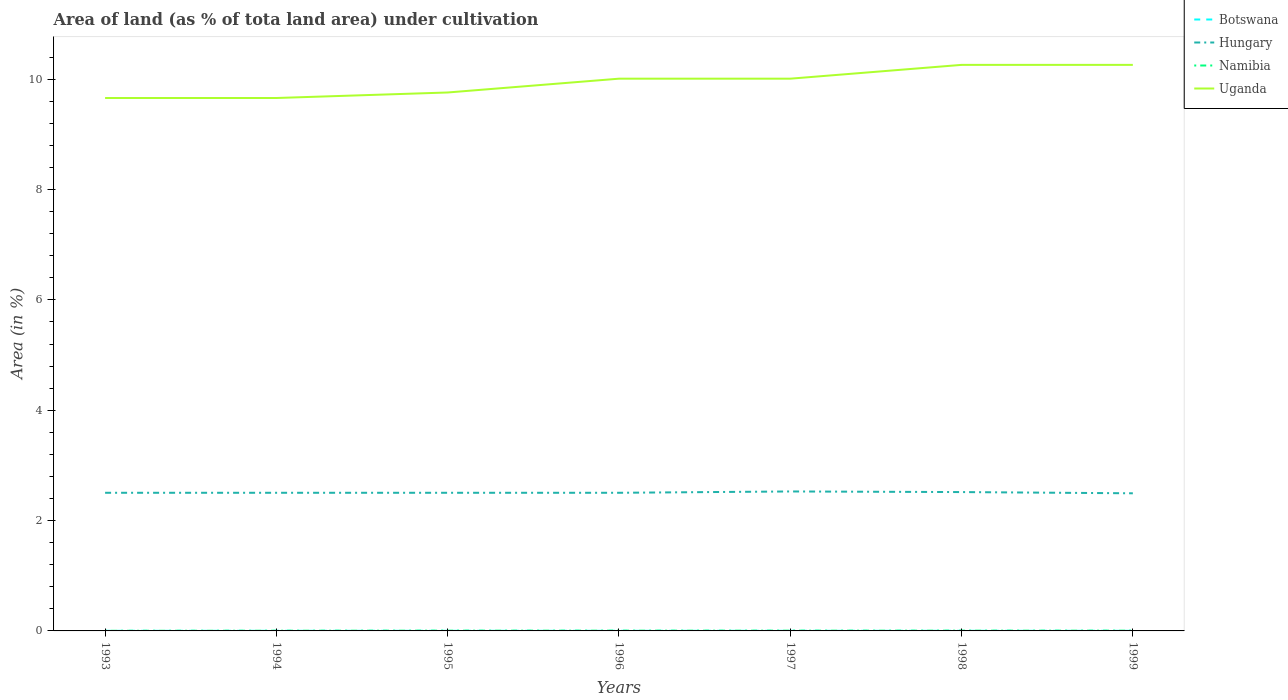Does the line corresponding to Namibia intersect with the line corresponding to Botswana?
Your answer should be very brief. No. Across all years, what is the maximum percentage of land under cultivation in Hungary?
Your answer should be compact. 2.49. In which year was the percentage of land under cultivation in Uganda maximum?
Offer a very short reply. 1993. What is the total percentage of land under cultivation in Uganda in the graph?
Your answer should be compact. -0.25. What is the difference between the highest and the second highest percentage of land under cultivation in Namibia?
Make the answer very short. 0. Where does the legend appear in the graph?
Provide a short and direct response. Top right. How many legend labels are there?
Your response must be concise. 4. How are the legend labels stacked?
Provide a short and direct response. Vertical. What is the title of the graph?
Give a very brief answer. Area of land (as % of tota land area) under cultivation. Does "Ghana" appear as one of the legend labels in the graph?
Make the answer very short. No. What is the label or title of the Y-axis?
Make the answer very short. Area (in %). What is the Area (in %) in Botswana in 1993?
Ensure brevity in your answer.  0. What is the Area (in %) in Hungary in 1993?
Keep it short and to the point. 2.5. What is the Area (in %) in Namibia in 1993?
Provide a succinct answer. 0. What is the Area (in %) in Uganda in 1993?
Make the answer very short. 9.66. What is the Area (in %) of Botswana in 1994?
Offer a terse response. 0. What is the Area (in %) of Hungary in 1994?
Provide a succinct answer. 2.5. What is the Area (in %) in Namibia in 1994?
Your answer should be very brief. 0. What is the Area (in %) of Uganda in 1994?
Ensure brevity in your answer.  9.66. What is the Area (in %) of Botswana in 1995?
Your response must be concise. 0. What is the Area (in %) in Hungary in 1995?
Offer a terse response. 2.5. What is the Area (in %) in Namibia in 1995?
Offer a terse response. 0. What is the Area (in %) in Uganda in 1995?
Keep it short and to the point. 9.76. What is the Area (in %) in Botswana in 1996?
Keep it short and to the point. 0. What is the Area (in %) of Hungary in 1996?
Your answer should be very brief. 2.5. What is the Area (in %) in Namibia in 1996?
Offer a terse response. 0. What is the Area (in %) of Uganda in 1996?
Your answer should be compact. 10.01. What is the Area (in %) of Botswana in 1997?
Your answer should be very brief. 0. What is the Area (in %) of Hungary in 1997?
Offer a terse response. 2.53. What is the Area (in %) of Namibia in 1997?
Give a very brief answer. 0. What is the Area (in %) of Uganda in 1997?
Your answer should be very brief. 10.01. What is the Area (in %) in Botswana in 1998?
Give a very brief answer. 0. What is the Area (in %) of Hungary in 1998?
Offer a terse response. 2.52. What is the Area (in %) of Namibia in 1998?
Your answer should be very brief. 0. What is the Area (in %) of Uganda in 1998?
Your response must be concise. 10.26. What is the Area (in %) in Botswana in 1999?
Your answer should be compact. 0. What is the Area (in %) in Hungary in 1999?
Give a very brief answer. 2.49. What is the Area (in %) of Namibia in 1999?
Make the answer very short. 0. What is the Area (in %) of Uganda in 1999?
Offer a terse response. 10.26. Across all years, what is the maximum Area (in %) of Botswana?
Make the answer very short. 0. Across all years, what is the maximum Area (in %) of Hungary?
Make the answer very short. 2.53. Across all years, what is the maximum Area (in %) in Namibia?
Your answer should be compact. 0. Across all years, what is the maximum Area (in %) of Uganda?
Offer a very short reply. 10.26. Across all years, what is the minimum Area (in %) in Botswana?
Offer a terse response. 0. Across all years, what is the minimum Area (in %) of Hungary?
Offer a very short reply. 2.49. Across all years, what is the minimum Area (in %) of Namibia?
Keep it short and to the point. 0. Across all years, what is the minimum Area (in %) of Uganda?
Your answer should be very brief. 9.66. What is the total Area (in %) of Botswana in the graph?
Provide a short and direct response. 0.01. What is the total Area (in %) of Hungary in the graph?
Give a very brief answer. 17.55. What is the total Area (in %) in Namibia in the graph?
Make the answer very short. 0.03. What is the total Area (in %) of Uganda in the graph?
Your answer should be very brief. 69.62. What is the difference between the Area (in %) in Botswana in 1993 and that in 1994?
Offer a very short reply. 0. What is the difference between the Area (in %) of Namibia in 1993 and that in 1994?
Ensure brevity in your answer.  -0. What is the difference between the Area (in %) in Hungary in 1993 and that in 1995?
Provide a short and direct response. 0. What is the difference between the Area (in %) of Namibia in 1993 and that in 1995?
Offer a terse response. -0. What is the difference between the Area (in %) in Uganda in 1993 and that in 1995?
Keep it short and to the point. -0.1. What is the difference between the Area (in %) of Namibia in 1993 and that in 1996?
Give a very brief answer. -0. What is the difference between the Area (in %) in Uganda in 1993 and that in 1996?
Provide a short and direct response. -0.35. What is the difference between the Area (in %) in Hungary in 1993 and that in 1997?
Keep it short and to the point. -0.02. What is the difference between the Area (in %) in Namibia in 1993 and that in 1997?
Your response must be concise. -0. What is the difference between the Area (in %) in Uganda in 1993 and that in 1997?
Give a very brief answer. -0.35. What is the difference between the Area (in %) of Hungary in 1993 and that in 1998?
Provide a short and direct response. -0.01. What is the difference between the Area (in %) in Namibia in 1993 and that in 1998?
Provide a succinct answer. -0. What is the difference between the Area (in %) of Uganda in 1993 and that in 1998?
Give a very brief answer. -0.6. What is the difference between the Area (in %) in Botswana in 1993 and that in 1999?
Your answer should be very brief. 0. What is the difference between the Area (in %) of Hungary in 1993 and that in 1999?
Offer a terse response. 0.01. What is the difference between the Area (in %) of Namibia in 1993 and that in 1999?
Provide a short and direct response. -0. What is the difference between the Area (in %) in Uganda in 1993 and that in 1999?
Give a very brief answer. -0.6. What is the difference between the Area (in %) of Namibia in 1994 and that in 1995?
Give a very brief answer. -0. What is the difference between the Area (in %) in Uganda in 1994 and that in 1995?
Your response must be concise. -0.1. What is the difference between the Area (in %) of Botswana in 1994 and that in 1996?
Make the answer very short. 0. What is the difference between the Area (in %) in Namibia in 1994 and that in 1996?
Offer a very short reply. -0. What is the difference between the Area (in %) of Uganda in 1994 and that in 1996?
Your answer should be compact. -0.35. What is the difference between the Area (in %) of Hungary in 1994 and that in 1997?
Keep it short and to the point. -0.02. What is the difference between the Area (in %) of Namibia in 1994 and that in 1997?
Your answer should be very brief. -0. What is the difference between the Area (in %) of Uganda in 1994 and that in 1997?
Provide a succinct answer. -0.35. What is the difference between the Area (in %) of Hungary in 1994 and that in 1998?
Offer a very short reply. -0.01. What is the difference between the Area (in %) in Namibia in 1994 and that in 1998?
Make the answer very short. -0. What is the difference between the Area (in %) in Uganda in 1994 and that in 1998?
Keep it short and to the point. -0.6. What is the difference between the Area (in %) in Hungary in 1994 and that in 1999?
Make the answer very short. 0.01. What is the difference between the Area (in %) of Namibia in 1994 and that in 1999?
Ensure brevity in your answer.  -0. What is the difference between the Area (in %) in Uganda in 1994 and that in 1999?
Your answer should be compact. -0.6. What is the difference between the Area (in %) in Uganda in 1995 and that in 1996?
Your answer should be very brief. -0.25. What is the difference between the Area (in %) of Botswana in 1995 and that in 1997?
Your answer should be very brief. 0. What is the difference between the Area (in %) in Hungary in 1995 and that in 1997?
Offer a very short reply. -0.02. What is the difference between the Area (in %) of Uganda in 1995 and that in 1997?
Offer a very short reply. -0.25. What is the difference between the Area (in %) of Hungary in 1995 and that in 1998?
Offer a very short reply. -0.01. What is the difference between the Area (in %) of Namibia in 1995 and that in 1998?
Your response must be concise. 0. What is the difference between the Area (in %) in Uganda in 1995 and that in 1998?
Ensure brevity in your answer.  -0.5. What is the difference between the Area (in %) in Hungary in 1995 and that in 1999?
Provide a short and direct response. 0.01. What is the difference between the Area (in %) of Uganda in 1995 and that in 1999?
Provide a succinct answer. -0.5. What is the difference between the Area (in %) in Botswana in 1996 and that in 1997?
Your answer should be compact. 0. What is the difference between the Area (in %) of Hungary in 1996 and that in 1997?
Give a very brief answer. -0.02. What is the difference between the Area (in %) in Uganda in 1996 and that in 1997?
Offer a terse response. 0. What is the difference between the Area (in %) in Botswana in 1996 and that in 1998?
Make the answer very short. 0. What is the difference between the Area (in %) of Hungary in 1996 and that in 1998?
Keep it short and to the point. -0.01. What is the difference between the Area (in %) in Namibia in 1996 and that in 1998?
Your answer should be compact. 0. What is the difference between the Area (in %) of Uganda in 1996 and that in 1998?
Keep it short and to the point. -0.25. What is the difference between the Area (in %) in Hungary in 1996 and that in 1999?
Your answer should be very brief. 0.01. What is the difference between the Area (in %) in Uganda in 1996 and that in 1999?
Your answer should be compact. -0.25. What is the difference between the Area (in %) of Botswana in 1997 and that in 1998?
Make the answer very short. 0. What is the difference between the Area (in %) of Hungary in 1997 and that in 1998?
Give a very brief answer. 0.01. What is the difference between the Area (in %) in Uganda in 1997 and that in 1998?
Keep it short and to the point. -0.25. What is the difference between the Area (in %) in Hungary in 1997 and that in 1999?
Your answer should be compact. 0.03. What is the difference between the Area (in %) of Namibia in 1997 and that in 1999?
Keep it short and to the point. 0. What is the difference between the Area (in %) of Uganda in 1997 and that in 1999?
Keep it short and to the point. -0.25. What is the difference between the Area (in %) of Botswana in 1998 and that in 1999?
Offer a very short reply. 0. What is the difference between the Area (in %) of Hungary in 1998 and that in 1999?
Keep it short and to the point. 0.02. What is the difference between the Area (in %) in Botswana in 1993 and the Area (in %) in Hungary in 1994?
Ensure brevity in your answer.  -2.5. What is the difference between the Area (in %) in Botswana in 1993 and the Area (in %) in Namibia in 1994?
Provide a succinct answer. -0. What is the difference between the Area (in %) of Botswana in 1993 and the Area (in %) of Uganda in 1994?
Your response must be concise. -9.66. What is the difference between the Area (in %) of Hungary in 1993 and the Area (in %) of Namibia in 1994?
Your answer should be compact. 2.5. What is the difference between the Area (in %) of Hungary in 1993 and the Area (in %) of Uganda in 1994?
Offer a very short reply. -7.16. What is the difference between the Area (in %) of Namibia in 1993 and the Area (in %) of Uganda in 1994?
Keep it short and to the point. -9.66. What is the difference between the Area (in %) of Botswana in 1993 and the Area (in %) of Hungary in 1995?
Offer a terse response. -2.5. What is the difference between the Area (in %) in Botswana in 1993 and the Area (in %) in Namibia in 1995?
Your response must be concise. -0. What is the difference between the Area (in %) of Botswana in 1993 and the Area (in %) of Uganda in 1995?
Your answer should be compact. -9.76. What is the difference between the Area (in %) of Hungary in 1993 and the Area (in %) of Namibia in 1995?
Provide a succinct answer. 2.5. What is the difference between the Area (in %) in Hungary in 1993 and the Area (in %) in Uganda in 1995?
Offer a terse response. -7.26. What is the difference between the Area (in %) in Namibia in 1993 and the Area (in %) in Uganda in 1995?
Ensure brevity in your answer.  -9.76. What is the difference between the Area (in %) in Botswana in 1993 and the Area (in %) in Hungary in 1996?
Your response must be concise. -2.5. What is the difference between the Area (in %) in Botswana in 1993 and the Area (in %) in Namibia in 1996?
Your answer should be compact. -0. What is the difference between the Area (in %) in Botswana in 1993 and the Area (in %) in Uganda in 1996?
Offer a very short reply. -10.01. What is the difference between the Area (in %) of Hungary in 1993 and the Area (in %) of Namibia in 1996?
Offer a terse response. 2.5. What is the difference between the Area (in %) in Hungary in 1993 and the Area (in %) in Uganda in 1996?
Offer a very short reply. -7.51. What is the difference between the Area (in %) of Namibia in 1993 and the Area (in %) of Uganda in 1996?
Make the answer very short. -10.01. What is the difference between the Area (in %) in Botswana in 1993 and the Area (in %) in Hungary in 1997?
Your response must be concise. -2.53. What is the difference between the Area (in %) of Botswana in 1993 and the Area (in %) of Namibia in 1997?
Make the answer very short. -0. What is the difference between the Area (in %) of Botswana in 1993 and the Area (in %) of Uganda in 1997?
Offer a terse response. -10.01. What is the difference between the Area (in %) in Hungary in 1993 and the Area (in %) in Namibia in 1997?
Make the answer very short. 2.5. What is the difference between the Area (in %) in Hungary in 1993 and the Area (in %) in Uganda in 1997?
Offer a terse response. -7.51. What is the difference between the Area (in %) in Namibia in 1993 and the Area (in %) in Uganda in 1997?
Your answer should be very brief. -10.01. What is the difference between the Area (in %) of Botswana in 1993 and the Area (in %) of Hungary in 1998?
Offer a very short reply. -2.51. What is the difference between the Area (in %) of Botswana in 1993 and the Area (in %) of Namibia in 1998?
Keep it short and to the point. -0. What is the difference between the Area (in %) of Botswana in 1993 and the Area (in %) of Uganda in 1998?
Your answer should be compact. -10.26. What is the difference between the Area (in %) of Hungary in 1993 and the Area (in %) of Namibia in 1998?
Your response must be concise. 2.5. What is the difference between the Area (in %) of Hungary in 1993 and the Area (in %) of Uganda in 1998?
Offer a terse response. -7.76. What is the difference between the Area (in %) of Namibia in 1993 and the Area (in %) of Uganda in 1998?
Offer a terse response. -10.26. What is the difference between the Area (in %) in Botswana in 1993 and the Area (in %) in Hungary in 1999?
Your answer should be compact. -2.49. What is the difference between the Area (in %) of Botswana in 1993 and the Area (in %) of Namibia in 1999?
Ensure brevity in your answer.  -0. What is the difference between the Area (in %) in Botswana in 1993 and the Area (in %) in Uganda in 1999?
Your answer should be compact. -10.26. What is the difference between the Area (in %) in Hungary in 1993 and the Area (in %) in Namibia in 1999?
Provide a short and direct response. 2.5. What is the difference between the Area (in %) of Hungary in 1993 and the Area (in %) of Uganda in 1999?
Your response must be concise. -7.76. What is the difference between the Area (in %) of Namibia in 1993 and the Area (in %) of Uganda in 1999?
Ensure brevity in your answer.  -10.26. What is the difference between the Area (in %) of Botswana in 1994 and the Area (in %) of Hungary in 1995?
Provide a succinct answer. -2.5. What is the difference between the Area (in %) in Botswana in 1994 and the Area (in %) in Namibia in 1995?
Make the answer very short. -0. What is the difference between the Area (in %) of Botswana in 1994 and the Area (in %) of Uganda in 1995?
Offer a very short reply. -9.76. What is the difference between the Area (in %) of Hungary in 1994 and the Area (in %) of Namibia in 1995?
Offer a very short reply. 2.5. What is the difference between the Area (in %) in Hungary in 1994 and the Area (in %) in Uganda in 1995?
Your answer should be very brief. -7.26. What is the difference between the Area (in %) in Namibia in 1994 and the Area (in %) in Uganda in 1995?
Your response must be concise. -9.76. What is the difference between the Area (in %) in Botswana in 1994 and the Area (in %) in Hungary in 1996?
Give a very brief answer. -2.5. What is the difference between the Area (in %) of Botswana in 1994 and the Area (in %) of Namibia in 1996?
Your answer should be compact. -0. What is the difference between the Area (in %) in Botswana in 1994 and the Area (in %) in Uganda in 1996?
Keep it short and to the point. -10.01. What is the difference between the Area (in %) of Hungary in 1994 and the Area (in %) of Namibia in 1996?
Keep it short and to the point. 2.5. What is the difference between the Area (in %) in Hungary in 1994 and the Area (in %) in Uganda in 1996?
Provide a succinct answer. -7.51. What is the difference between the Area (in %) of Namibia in 1994 and the Area (in %) of Uganda in 1996?
Provide a succinct answer. -10.01. What is the difference between the Area (in %) of Botswana in 1994 and the Area (in %) of Hungary in 1997?
Make the answer very short. -2.53. What is the difference between the Area (in %) in Botswana in 1994 and the Area (in %) in Namibia in 1997?
Keep it short and to the point. -0. What is the difference between the Area (in %) in Botswana in 1994 and the Area (in %) in Uganda in 1997?
Make the answer very short. -10.01. What is the difference between the Area (in %) of Hungary in 1994 and the Area (in %) of Namibia in 1997?
Provide a succinct answer. 2.5. What is the difference between the Area (in %) of Hungary in 1994 and the Area (in %) of Uganda in 1997?
Offer a terse response. -7.51. What is the difference between the Area (in %) of Namibia in 1994 and the Area (in %) of Uganda in 1997?
Make the answer very short. -10.01. What is the difference between the Area (in %) in Botswana in 1994 and the Area (in %) in Hungary in 1998?
Make the answer very short. -2.51. What is the difference between the Area (in %) of Botswana in 1994 and the Area (in %) of Namibia in 1998?
Keep it short and to the point. -0. What is the difference between the Area (in %) in Botswana in 1994 and the Area (in %) in Uganda in 1998?
Keep it short and to the point. -10.26. What is the difference between the Area (in %) in Hungary in 1994 and the Area (in %) in Namibia in 1998?
Provide a succinct answer. 2.5. What is the difference between the Area (in %) in Hungary in 1994 and the Area (in %) in Uganda in 1998?
Ensure brevity in your answer.  -7.76. What is the difference between the Area (in %) in Namibia in 1994 and the Area (in %) in Uganda in 1998?
Make the answer very short. -10.26. What is the difference between the Area (in %) in Botswana in 1994 and the Area (in %) in Hungary in 1999?
Ensure brevity in your answer.  -2.49. What is the difference between the Area (in %) in Botswana in 1994 and the Area (in %) in Namibia in 1999?
Your response must be concise. -0. What is the difference between the Area (in %) in Botswana in 1994 and the Area (in %) in Uganda in 1999?
Offer a very short reply. -10.26. What is the difference between the Area (in %) of Hungary in 1994 and the Area (in %) of Namibia in 1999?
Your answer should be very brief. 2.5. What is the difference between the Area (in %) in Hungary in 1994 and the Area (in %) in Uganda in 1999?
Keep it short and to the point. -7.76. What is the difference between the Area (in %) of Namibia in 1994 and the Area (in %) of Uganda in 1999?
Make the answer very short. -10.26. What is the difference between the Area (in %) of Botswana in 1995 and the Area (in %) of Hungary in 1996?
Offer a terse response. -2.5. What is the difference between the Area (in %) in Botswana in 1995 and the Area (in %) in Namibia in 1996?
Give a very brief answer. -0. What is the difference between the Area (in %) in Botswana in 1995 and the Area (in %) in Uganda in 1996?
Your response must be concise. -10.01. What is the difference between the Area (in %) in Hungary in 1995 and the Area (in %) in Namibia in 1996?
Keep it short and to the point. 2.5. What is the difference between the Area (in %) of Hungary in 1995 and the Area (in %) of Uganda in 1996?
Give a very brief answer. -7.51. What is the difference between the Area (in %) in Namibia in 1995 and the Area (in %) in Uganda in 1996?
Your response must be concise. -10. What is the difference between the Area (in %) of Botswana in 1995 and the Area (in %) of Hungary in 1997?
Give a very brief answer. -2.53. What is the difference between the Area (in %) in Botswana in 1995 and the Area (in %) in Namibia in 1997?
Give a very brief answer. -0. What is the difference between the Area (in %) in Botswana in 1995 and the Area (in %) in Uganda in 1997?
Make the answer very short. -10.01. What is the difference between the Area (in %) in Hungary in 1995 and the Area (in %) in Namibia in 1997?
Make the answer very short. 2.5. What is the difference between the Area (in %) in Hungary in 1995 and the Area (in %) in Uganda in 1997?
Provide a succinct answer. -7.51. What is the difference between the Area (in %) of Namibia in 1995 and the Area (in %) of Uganda in 1997?
Keep it short and to the point. -10. What is the difference between the Area (in %) in Botswana in 1995 and the Area (in %) in Hungary in 1998?
Offer a terse response. -2.51. What is the difference between the Area (in %) of Botswana in 1995 and the Area (in %) of Namibia in 1998?
Offer a terse response. -0. What is the difference between the Area (in %) of Botswana in 1995 and the Area (in %) of Uganda in 1998?
Give a very brief answer. -10.26. What is the difference between the Area (in %) in Hungary in 1995 and the Area (in %) in Namibia in 1998?
Provide a short and direct response. 2.5. What is the difference between the Area (in %) of Hungary in 1995 and the Area (in %) of Uganda in 1998?
Keep it short and to the point. -7.76. What is the difference between the Area (in %) of Namibia in 1995 and the Area (in %) of Uganda in 1998?
Offer a terse response. -10.25. What is the difference between the Area (in %) in Botswana in 1995 and the Area (in %) in Hungary in 1999?
Ensure brevity in your answer.  -2.49. What is the difference between the Area (in %) in Botswana in 1995 and the Area (in %) in Namibia in 1999?
Offer a terse response. -0. What is the difference between the Area (in %) in Botswana in 1995 and the Area (in %) in Uganda in 1999?
Your response must be concise. -10.26. What is the difference between the Area (in %) in Hungary in 1995 and the Area (in %) in Namibia in 1999?
Make the answer very short. 2.5. What is the difference between the Area (in %) in Hungary in 1995 and the Area (in %) in Uganda in 1999?
Give a very brief answer. -7.76. What is the difference between the Area (in %) of Namibia in 1995 and the Area (in %) of Uganda in 1999?
Provide a succinct answer. -10.25. What is the difference between the Area (in %) of Botswana in 1996 and the Area (in %) of Hungary in 1997?
Offer a terse response. -2.53. What is the difference between the Area (in %) in Botswana in 1996 and the Area (in %) in Namibia in 1997?
Your response must be concise. -0. What is the difference between the Area (in %) of Botswana in 1996 and the Area (in %) of Uganda in 1997?
Keep it short and to the point. -10.01. What is the difference between the Area (in %) in Hungary in 1996 and the Area (in %) in Namibia in 1997?
Your answer should be compact. 2.5. What is the difference between the Area (in %) in Hungary in 1996 and the Area (in %) in Uganda in 1997?
Offer a terse response. -7.51. What is the difference between the Area (in %) in Namibia in 1996 and the Area (in %) in Uganda in 1997?
Give a very brief answer. -10. What is the difference between the Area (in %) of Botswana in 1996 and the Area (in %) of Hungary in 1998?
Give a very brief answer. -2.51. What is the difference between the Area (in %) of Botswana in 1996 and the Area (in %) of Namibia in 1998?
Your answer should be very brief. -0. What is the difference between the Area (in %) of Botswana in 1996 and the Area (in %) of Uganda in 1998?
Ensure brevity in your answer.  -10.26. What is the difference between the Area (in %) of Hungary in 1996 and the Area (in %) of Namibia in 1998?
Your response must be concise. 2.5. What is the difference between the Area (in %) of Hungary in 1996 and the Area (in %) of Uganda in 1998?
Offer a very short reply. -7.76. What is the difference between the Area (in %) of Namibia in 1996 and the Area (in %) of Uganda in 1998?
Your response must be concise. -10.25. What is the difference between the Area (in %) in Botswana in 1996 and the Area (in %) in Hungary in 1999?
Offer a terse response. -2.49. What is the difference between the Area (in %) in Botswana in 1996 and the Area (in %) in Namibia in 1999?
Provide a succinct answer. -0. What is the difference between the Area (in %) in Botswana in 1996 and the Area (in %) in Uganda in 1999?
Your response must be concise. -10.26. What is the difference between the Area (in %) in Hungary in 1996 and the Area (in %) in Namibia in 1999?
Ensure brevity in your answer.  2.5. What is the difference between the Area (in %) of Hungary in 1996 and the Area (in %) of Uganda in 1999?
Your answer should be compact. -7.76. What is the difference between the Area (in %) in Namibia in 1996 and the Area (in %) in Uganda in 1999?
Provide a succinct answer. -10.25. What is the difference between the Area (in %) of Botswana in 1997 and the Area (in %) of Hungary in 1998?
Your answer should be compact. -2.51. What is the difference between the Area (in %) of Botswana in 1997 and the Area (in %) of Namibia in 1998?
Your answer should be very brief. -0. What is the difference between the Area (in %) in Botswana in 1997 and the Area (in %) in Uganda in 1998?
Give a very brief answer. -10.26. What is the difference between the Area (in %) in Hungary in 1997 and the Area (in %) in Namibia in 1998?
Keep it short and to the point. 2.52. What is the difference between the Area (in %) of Hungary in 1997 and the Area (in %) of Uganda in 1998?
Make the answer very short. -7.73. What is the difference between the Area (in %) in Namibia in 1997 and the Area (in %) in Uganda in 1998?
Provide a succinct answer. -10.25. What is the difference between the Area (in %) of Botswana in 1997 and the Area (in %) of Hungary in 1999?
Give a very brief answer. -2.49. What is the difference between the Area (in %) in Botswana in 1997 and the Area (in %) in Namibia in 1999?
Offer a terse response. -0. What is the difference between the Area (in %) in Botswana in 1997 and the Area (in %) in Uganda in 1999?
Make the answer very short. -10.26. What is the difference between the Area (in %) in Hungary in 1997 and the Area (in %) in Namibia in 1999?
Offer a terse response. 2.52. What is the difference between the Area (in %) of Hungary in 1997 and the Area (in %) of Uganda in 1999?
Your answer should be compact. -7.73. What is the difference between the Area (in %) of Namibia in 1997 and the Area (in %) of Uganda in 1999?
Keep it short and to the point. -10.25. What is the difference between the Area (in %) in Botswana in 1998 and the Area (in %) in Hungary in 1999?
Your answer should be very brief. -2.49. What is the difference between the Area (in %) of Botswana in 1998 and the Area (in %) of Namibia in 1999?
Provide a short and direct response. -0. What is the difference between the Area (in %) of Botswana in 1998 and the Area (in %) of Uganda in 1999?
Give a very brief answer. -10.26. What is the difference between the Area (in %) of Hungary in 1998 and the Area (in %) of Namibia in 1999?
Offer a terse response. 2.51. What is the difference between the Area (in %) of Hungary in 1998 and the Area (in %) of Uganda in 1999?
Offer a terse response. -7.74. What is the difference between the Area (in %) of Namibia in 1998 and the Area (in %) of Uganda in 1999?
Offer a very short reply. -10.25. What is the average Area (in %) in Botswana per year?
Make the answer very short. 0. What is the average Area (in %) in Hungary per year?
Offer a terse response. 2.51. What is the average Area (in %) of Namibia per year?
Give a very brief answer. 0. What is the average Area (in %) of Uganda per year?
Provide a succinct answer. 9.95. In the year 1993, what is the difference between the Area (in %) of Botswana and Area (in %) of Hungary?
Provide a succinct answer. -2.5. In the year 1993, what is the difference between the Area (in %) of Botswana and Area (in %) of Namibia?
Provide a short and direct response. -0. In the year 1993, what is the difference between the Area (in %) in Botswana and Area (in %) in Uganda?
Ensure brevity in your answer.  -9.66. In the year 1993, what is the difference between the Area (in %) in Hungary and Area (in %) in Namibia?
Provide a short and direct response. 2.5. In the year 1993, what is the difference between the Area (in %) of Hungary and Area (in %) of Uganda?
Offer a terse response. -7.16. In the year 1993, what is the difference between the Area (in %) in Namibia and Area (in %) in Uganda?
Give a very brief answer. -9.66. In the year 1994, what is the difference between the Area (in %) in Botswana and Area (in %) in Hungary?
Offer a terse response. -2.5. In the year 1994, what is the difference between the Area (in %) in Botswana and Area (in %) in Namibia?
Your answer should be compact. -0. In the year 1994, what is the difference between the Area (in %) in Botswana and Area (in %) in Uganda?
Offer a very short reply. -9.66. In the year 1994, what is the difference between the Area (in %) in Hungary and Area (in %) in Namibia?
Your answer should be compact. 2.5. In the year 1994, what is the difference between the Area (in %) in Hungary and Area (in %) in Uganda?
Provide a short and direct response. -7.16. In the year 1994, what is the difference between the Area (in %) in Namibia and Area (in %) in Uganda?
Provide a succinct answer. -9.66. In the year 1995, what is the difference between the Area (in %) in Botswana and Area (in %) in Hungary?
Your answer should be compact. -2.5. In the year 1995, what is the difference between the Area (in %) in Botswana and Area (in %) in Namibia?
Make the answer very short. -0. In the year 1995, what is the difference between the Area (in %) in Botswana and Area (in %) in Uganda?
Offer a terse response. -9.76. In the year 1995, what is the difference between the Area (in %) of Hungary and Area (in %) of Namibia?
Provide a short and direct response. 2.5. In the year 1995, what is the difference between the Area (in %) of Hungary and Area (in %) of Uganda?
Offer a very short reply. -7.26. In the year 1995, what is the difference between the Area (in %) of Namibia and Area (in %) of Uganda?
Your answer should be very brief. -9.75. In the year 1996, what is the difference between the Area (in %) of Botswana and Area (in %) of Hungary?
Your response must be concise. -2.5. In the year 1996, what is the difference between the Area (in %) of Botswana and Area (in %) of Namibia?
Offer a very short reply. -0. In the year 1996, what is the difference between the Area (in %) of Botswana and Area (in %) of Uganda?
Keep it short and to the point. -10.01. In the year 1996, what is the difference between the Area (in %) of Hungary and Area (in %) of Namibia?
Offer a very short reply. 2.5. In the year 1996, what is the difference between the Area (in %) in Hungary and Area (in %) in Uganda?
Ensure brevity in your answer.  -7.51. In the year 1996, what is the difference between the Area (in %) of Namibia and Area (in %) of Uganda?
Offer a very short reply. -10. In the year 1997, what is the difference between the Area (in %) in Botswana and Area (in %) in Hungary?
Your answer should be very brief. -2.53. In the year 1997, what is the difference between the Area (in %) in Botswana and Area (in %) in Namibia?
Your answer should be very brief. -0. In the year 1997, what is the difference between the Area (in %) in Botswana and Area (in %) in Uganda?
Offer a terse response. -10.01. In the year 1997, what is the difference between the Area (in %) in Hungary and Area (in %) in Namibia?
Provide a succinct answer. 2.52. In the year 1997, what is the difference between the Area (in %) of Hungary and Area (in %) of Uganda?
Keep it short and to the point. -7.48. In the year 1997, what is the difference between the Area (in %) in Namibia and Area (in %) in Uganda?
Make the answer very short. -10. In the year 1998, what is the difference between the Area (in %) of Botswana and Area (in %) of Hungary?
Your answer should be compact. -2.51. In the year 1998, what is the difference between the Area (in %) of Botswana and Area (in %) of Namibia?
Offer a terse response. -0. In the year 1998, what is the difference between the Area (in %) of Botswana and Area (in %) of Uganda?
Your response must be concise. -10.26. In the year 1998, what is the difference between the Area (in %) of Hungary and Area (in %) of Namibia?
Ensure brevity in your answer.  2.51. In the year 1998, what is the difference between the Area (in %) in Hungary and Area (in %) in Uganda?
Give a very brief answer. -7.74. In the year 1998, what is the difference between the Area (in %) of Namibia and Area (in %) of Uganda?
Ensure brevity in your answer.  -10.25. In the year 1999, what is the difference between the Area (in %) in Botswana and Area (in %) in Hungary?
Your response must be concise. -2.49. In the year 1999, what is the difference between the Area (in %) of Botswana and Area (in %) of Namibia?
Give a very brief answer. -0. In the year 1999, what is the difference between the Area (in %) of Botswana and Area (in %) of Uganda?
Make the answer very short. -10.26. In the year 1999, what is the difference between the Area (in %) of Hungary and Area (in %) of Namibia?
Your answer should be compact. 2.49. In the year 1999, what is the difference between the Area (in %) of Hungary and Area (in %) of Uganda?
Offer a very short reply. -7.77. In the year 1999, what is the difference between the Area (in %) of Namibia and Area (in %) of Uganda?
Offer a very short reply. -10.25. What is the ratio of the Area (in %) in Uganda in 1993 to that in 1994?
Your answer should be very brief. 1. What is the ratio of the Area (in %) of Botswana in 1993 to that in 1995?
Give a very brief answer. 1. What is the ratio of the Area (in %) of Namibia in 1993 to that in 1995?
Your answer should be compact. 0.5. What is the ratio of the Area (in %) of Botswana in 1993 to that in 1996?
Provide a short and direct response. 1. What is the ratio of the Area (in %) of Namibia in 1993 to that in 1997?
Ensure brevity in your answer.  0.5. What is the ratio of the Area (in %) in Uganda in 1993 to that in 1998?
Make the answer very short. 0.94. What is the ratio of the Area (in %) of Botswana in 1993 to that in 1999?
Your answer should be very brief. 1. What is the ratio of the Area (in %) in Hungary in 1993 to that in 1999?
Your response must be concise. 1. What is the ratio of the Area (in %) in Uganda in 1993 to that in 1999?
Provide a short and direct response. 0.94. What is the ratio of the Area (in %) of Hungary in 1994 to that in 1995?
Your answer should be very brief. 1. What is the ratio of the Area (in %) of Namibia in 1994 to that in 1995?
Give a very brief answer. 0.75. What is the ratio of the Area (in %) in Uganda in 1994 to that in 1995?
Provide a short and direct response. 0.99. What is the ratio of the Area (in %) of Botswana in 1994 to that in 1996?
Provide a succinct answer. 1. What is the ratio of the Area (in %) in Hungary in 1994 to that in 1996?
Offer a terse response. 1. What is the ratio of the Area (in %) in Uganda in 1994 to that in 1997?
Ensure brevity in your answer.  0.96. What is the ratio of the Area (in %) of Hungary in 1994 to that in 1998?
Provide a short and direct response. 0.99. What is the ratio of the Area (in %) in Namibia in 1994 to that in 1998?
Make the answer very short. 0.75. What is the ratio of the Area (in %) of Uganda in 1994 to that in 1998?
Ensure brevity in your answer.  0.94. What is the ratio of the Area (in %) in Namibia in 1994 to that in 1999?
Your answer should be compact. 0.75. What is the ratio of the Area (in %) of Uganda in 1994 to that in 1999?
Offer a terse response. 0.94. What is the ratio of the Area (in %) of Botswana in 1995 to that in 1996?
Your answer should be very brief. 1. What is the ratio of the Area (in %) of Hungary in 1995 to that in 1996?
Your answer should be compact. 1. What is the ratio of the Area (in %) of Namibia in 1995 to that in 1997?
Ensure brevity in your answer.  1. What is the ratio of the Area (in %) in Botswana in 1995 to that in 1998?
Offer a terse response. 1. What is the ratio of the Area (in %) in Hungary in 1995 to that in 1998?
Make the answer very short. 0.99. What is the ratio of the Area (in %) in Uganda in 1995 to that in 1998?
Your response must be concise. 0.95. What is the ratio of the Area (in %) in Botswana in 1995 to that in 1999?
Make the answer very short. 1. What is the ratio of the Area (in %) of Namibia in 1995 to that in 1999?
Ensure brevity in your answer.  1. What is the ratio of the Area (in %) of Uganda in 1995 to that in 1999?
Ensure brevity in your answer.  0.95. What is the ratio of the Area (in %) in Hungary in 1996 to that in 1997?
Ensure brevity in your answer.  0.99. What is the ratio of the Area (in %) of Namibia in 1996 to that in 1998?
Ensure brevity in your answer.  1. What is the ratio of the Area (in %) in Uganda in 1996 to that in 1998?
Give a very brief answer. 0.98. What is the ratio of the Area (in %) in Namibia in 1996 to that in 1999?
Provide a succinct answer. 1. What is the ratio of the Area (in %) of Uganda in 1996 to that in 1999?
Your answer should be compact. 0.98. What is the ratio of the Area (in %) of Hungary in 1997 to that in 1998?
Provide a succinct answer. 1. What is the ratio of the Area (in %) of Namibia in 1997 to that in 1998?
Offer a very short reply. 1. What is the ratio of the Area (in %) of Uganda in 1997 to that in 1998?
Keep it short and to the point. 0.98. What is the ratio of the Area (in %) in Botswana in 1997 to that in 1999?
Make the answer very short. 1. What is the ratio of the Area (in %) in Hungary in 1997 to that in 1999?
Provide a short and direct response. 1.01. What is the ratio of the Area (in %) of Uganda in 1997 to that in 1999?
Your response must be concise. 0.98. What is the ratio of the Area (in %) in Botswana in 1998 to that in 1999?
Provide a succinct answer. 1. What is the ratio of the Area (in %) in Hungary in 1998 to that in 1999?
Offer a very short reply. 1.01. What is the ratio of the Area (in %) of Uganda in 1998 to that in 1999?
Give a very brief answer. 1. What is the difference between the highest and the second highest Area (in %) in Hungary?
Provide a short and direct response. 0.01. What is the difference between the highest and the second highest Area (in %) in Namibia?
Provide a short and direct response. 0. What is the difference between the highest and the lowest Area (in %) of Botswana?
Make the answer very short. 0. What is the difference between the highest and the lowest Area (in %) of Hungary?
Ensure brevity in your answer.  0.03. What is the difference between the highest and the lowest Area (in %) of Namibia?
Your answer should be very brief. 0. What is the difference between the highest and the lowest Area (in %) in Uganda?
Provide a short and direct response. 0.6. 